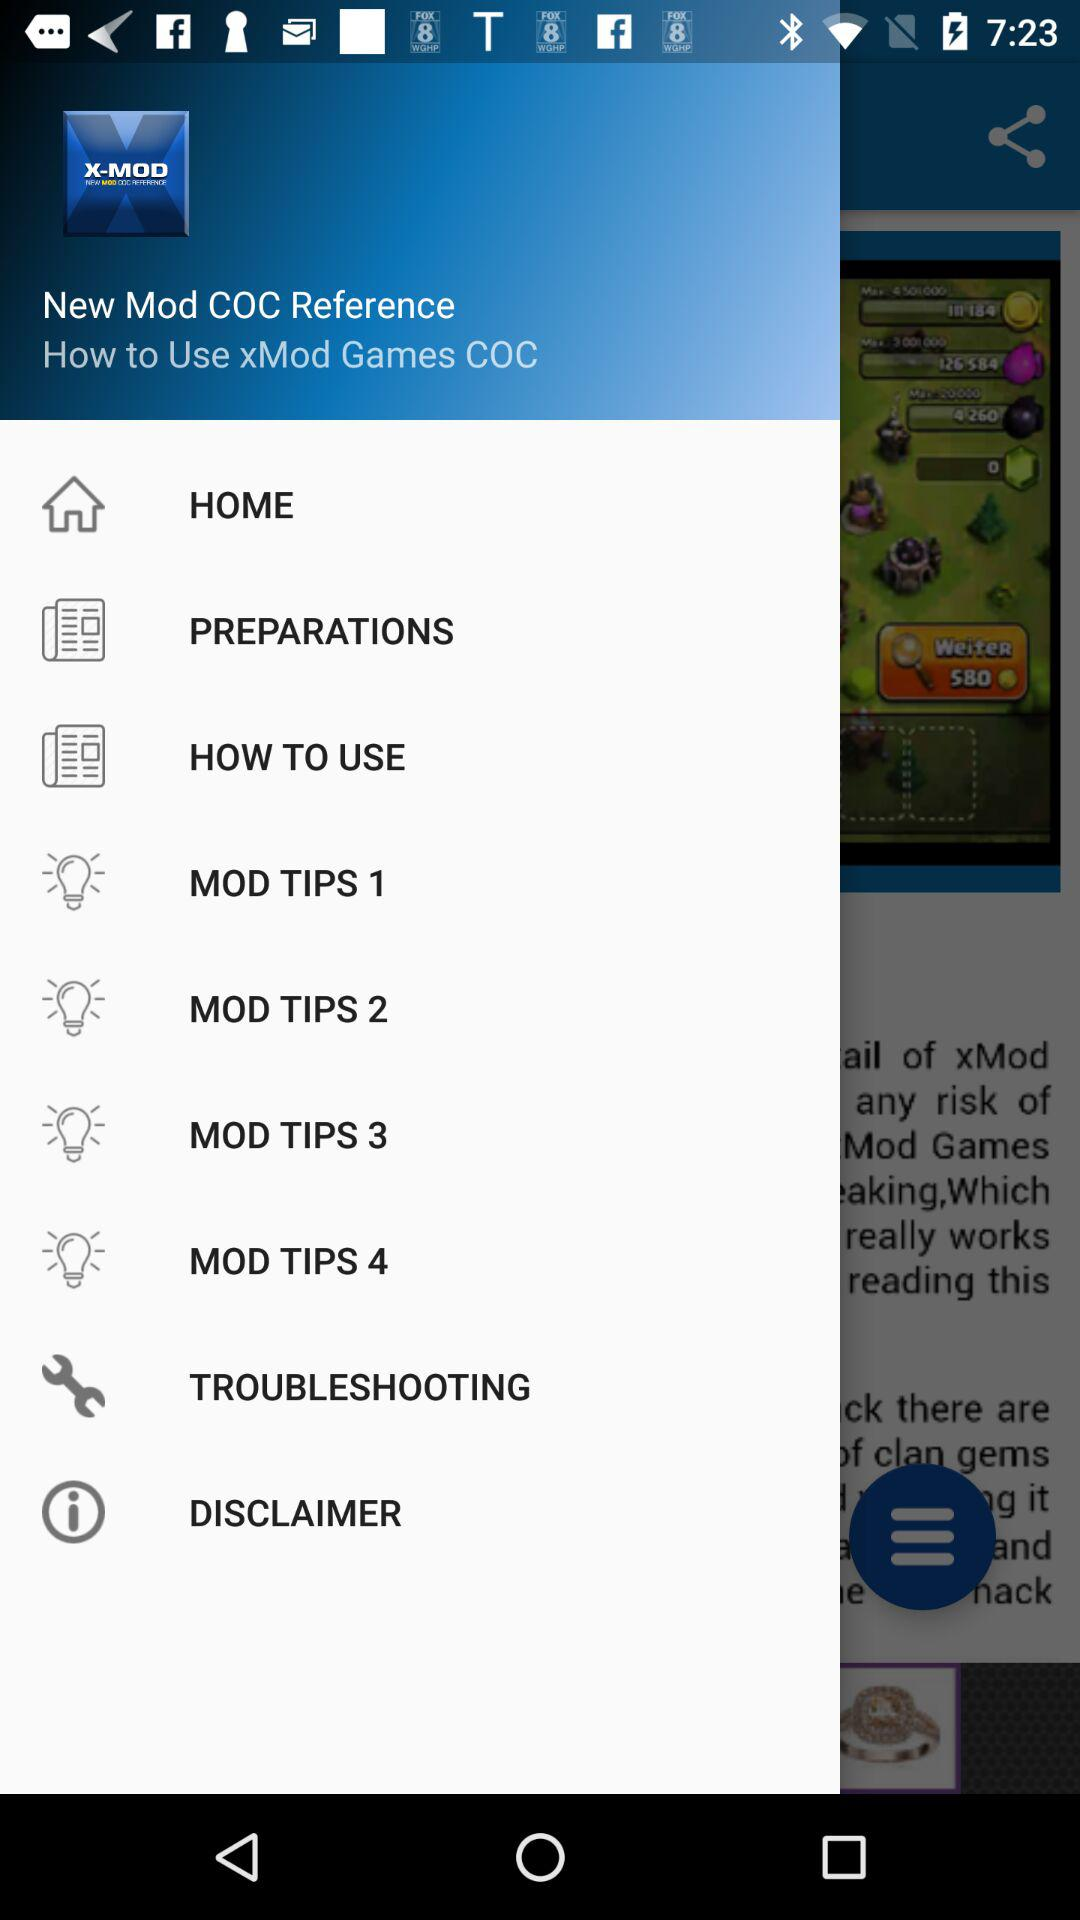How many more MOD TIPS are there than PREPARATIONS?
Answer the question using a single word or phrase. 3 